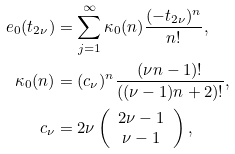Convert formula to latex. <formula><loc_0><loc_0><loc_500><loc_500>e _ { 0 } ( t _ { 2 \nu } ) & = \sum _ { j = 1 } ^ { \infty } \kappa _ { 0 } ( n ) \frac { ( - t _ { 2 \nu } ) ^ { n } } { n ! } , \\ \kappa _ { 0 } ( n ) & = ( c _ { \nu } ) ^ { n } \frac { ( \nu n - 1 ) ! } { ( ( \nu - 1 ) n + 2 ) ! } , \\ c _ { \nu } & = 2 \nu \left ( \begin{array} { c } 2 \nu - 1 \\ \nu - 1 \\ \end{array} \right ) ,</formula> 